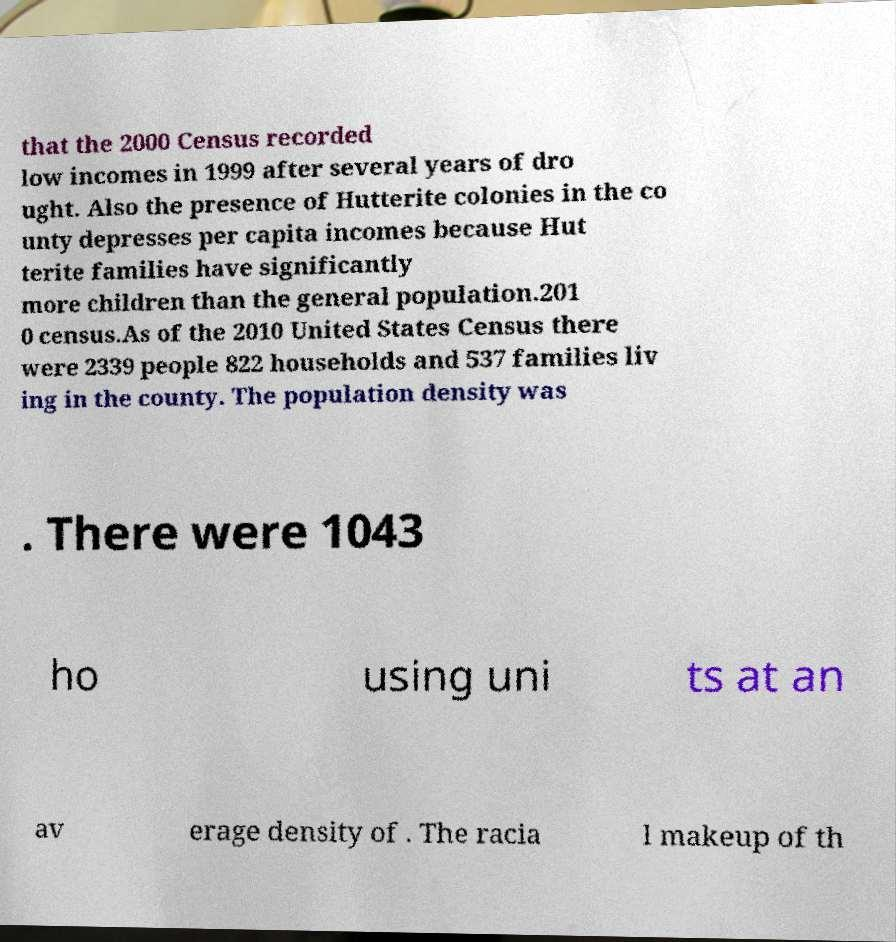Please read and relay the text visible in this image. What does it say? that the 2000 Census recorded low incomes in 1999 after several years of dro ught. Also the presence of Hutterite colonies in the co unty depresses per capita incomes because Hut terite families have significantly more children than the general population.201 0 census.As of the 2010 United States Census there were 2339 people 822 households and 537 families liv ing in the county. The population density was . There were 1043 ho using uni ts at an av erage density of . The racia l makeup of th 